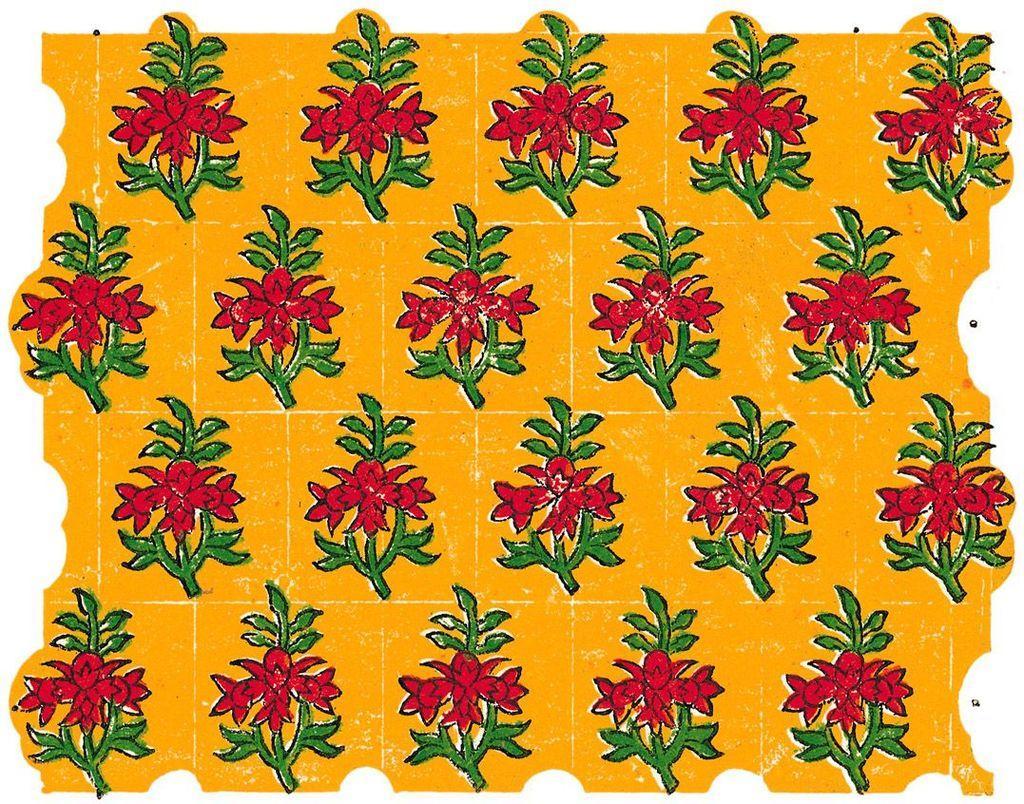Describe this image in one or two sentences. In the image there is a flower plant design on a yellow background. 